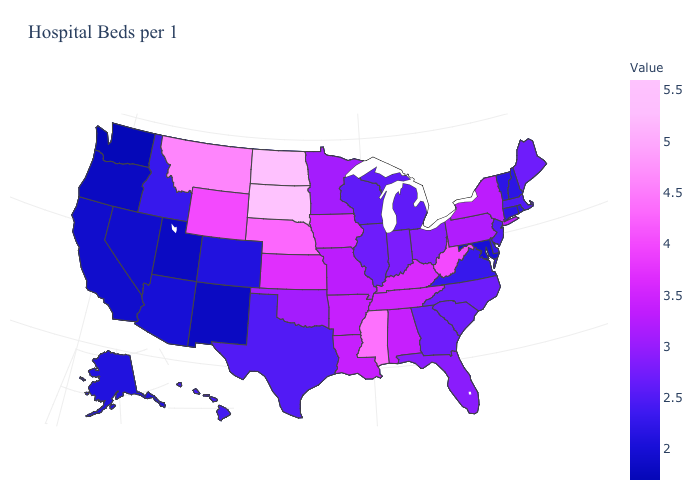Does Texas have the lowest value in the USA?
Answer briefly. No. Is the legend a continuous bar?
Write a very short answer. Yes. Does New York have the highest value in the Northeast?
Be succinct. Yes. Does the map have missing data?
Answer briefly. No. Does Tennessee have a higher value than West Virginia?
Be succinct. No. 